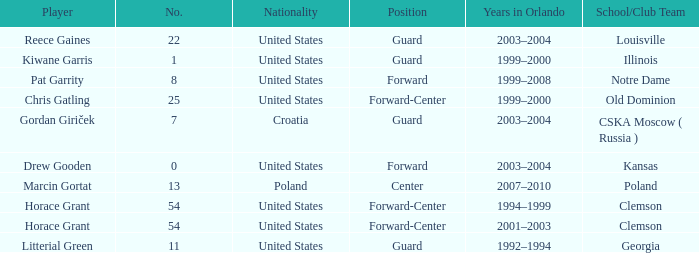How many team members does notre dame have? 1.0. 